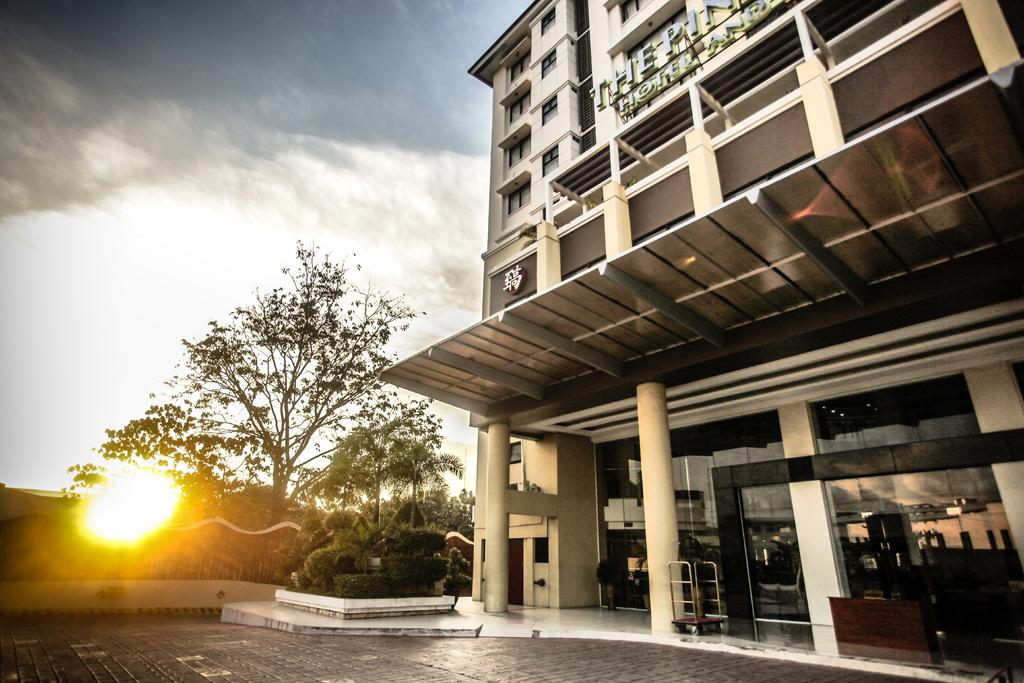What can be seen in the sky in the background of the image? There are clouds in the sky in the background of the image. What other elements can be seen in the background of the image? There are trees, light, and plants visible in the background. What is located on the right side of the image? There is a building on the right side of the image. What features does the building have? The building has windows and glass walls. What object is present near the building on the right side of the image? There is a luggage trolley on the right side of the image. What type of wrench is being used to adjust the elbow of the building in the image? There is no wrench or elbow present in the image; the building has glass walls and windows. 